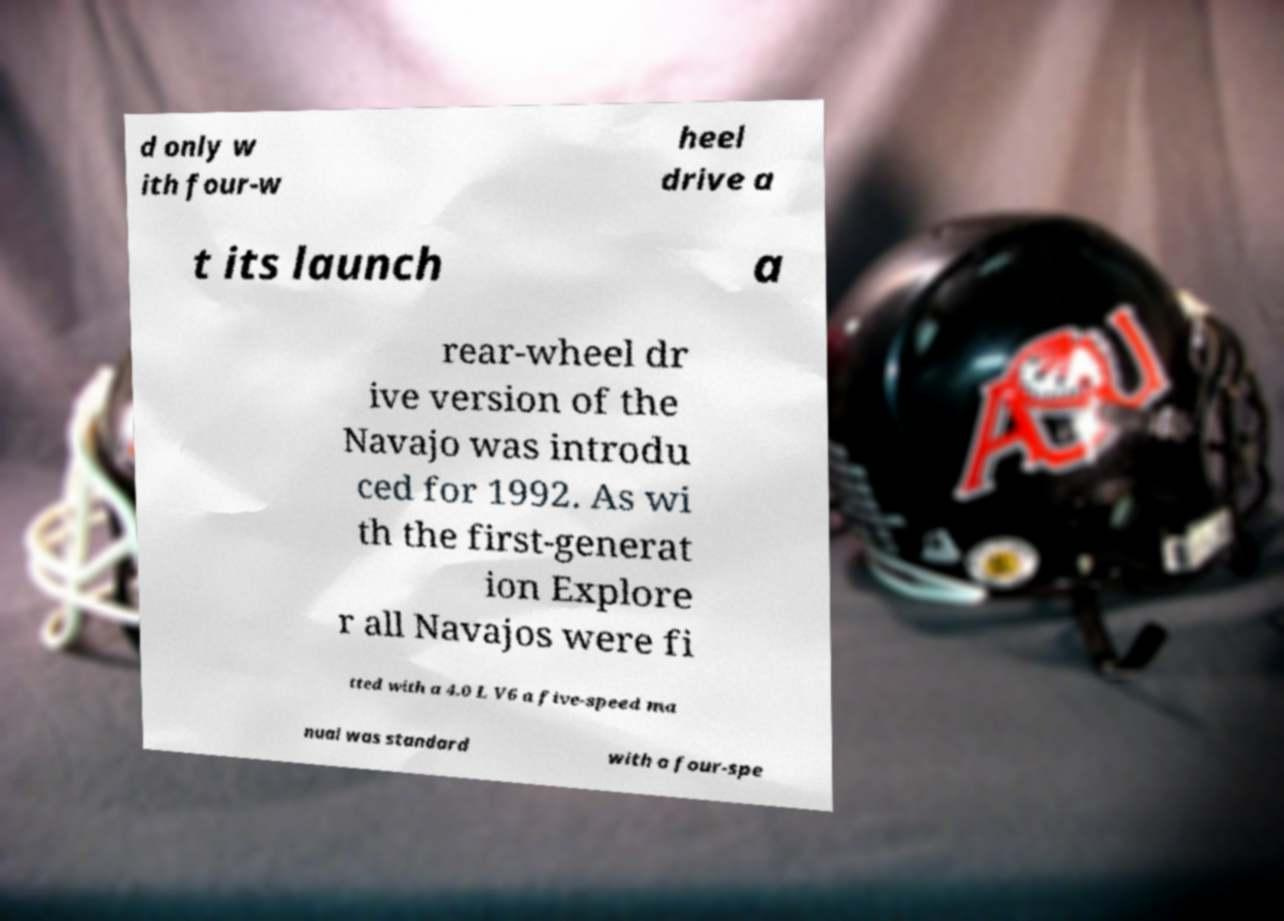Could you assist in decoding the text presented in this image and type it out clearly? d only w ith four-w heel drive a t its launch a rear-wheel dr ive version of the Navajo was introdu ced for 1992. As wi th the first-generat ion Explore r all Navajos were fi tted with a 4.0 L V6 a five-speed ma nual was standard with a four-spe 